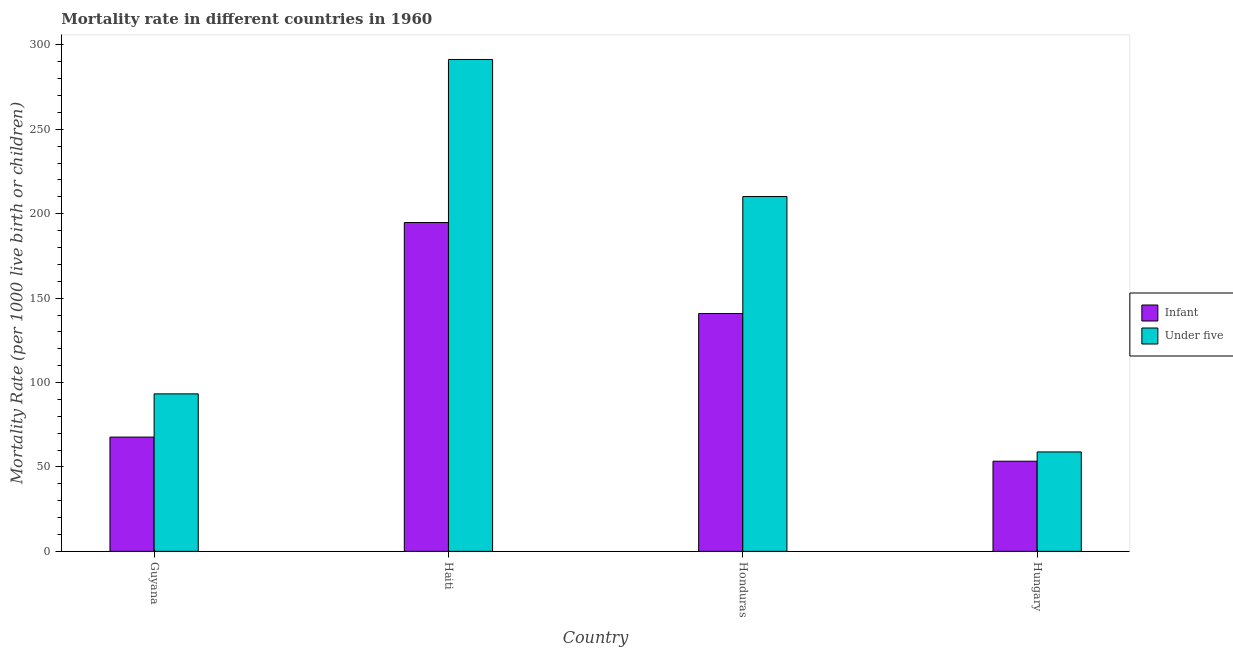Are the number of bars per tick equal to the number of legend labels?
Provide a succinct answer. Yes. How many bars are there on the 2nd tick from the left?
Your answer should be very brief. 2. How many bars are there on the 2nd tick from the right?
Offer a very short reply. 2. What is the label of the 2nd group of bars from the left?
Offer a terse response. Haiti. What is the infant mortality rate in Honduras?
Offer a very short reply. 140.9. Across all countries, what is the maximum infant mortality rate?
Give a very brief answer. 194.8. Across all countries, what is the minimum under-5 mortality rate?
Your answer should be compact. 58.9. In which country was the under-5 mortality rate maximum?
Your answer should be very brief. Haiti. In which country was the under-5 mortality rate minimum?
Your response must be concise. Hungary. What is the total infant mortality rate in the graph?
Your answer should be very brief. 456.8. What is the difference between the infant mortality rate in Guyana and that in Honduras?
Your response must be concise. -73.2. What is the difference between the infant mortality rate in Guyana and the under-5 mortality rate in Honduras?
Give a very brief answer. -142.5. What is the average under-5 mortality rate per country?
Your answer should be compact. 163.45. What is the difference between the infant mortality rate and under-5 mortality rate in Guyana?
Provide a succinct answer. -25.6. In how many countries, is the infant mortality rate greater than 290 ?
Ensure brevity in your answer.  0. What is the ratio of the infant mortality rate in Guyana to that in Honduras?
Your response must be concise. 0.48. What is the difference between the highest and the second highest infant mortality rate?
Your answer should be very brief. 53.9. What is the difference between the highest and the lowest infant mortality rate?
Ensure brevity in your answer.  141.4. In how many countries, is the infant mortality rate greater than the average infant mortality rate taken over all countries?
Provide a succinct answer. 2. Is the sum of the under-5 mortality rate in Guyana and Hungary greater than the maximum infant mortality rate across all countries?
Give a very brief answer. No. What does the 2nd bar from the left in Guyana represents?
Give a very brief answer. Under five. What does the 1st bar from the right in Hungary represents?
Provide a short and direct response. Under five. Are all the bars in the graph horizontal?
Make the answer very short. No. Does the graph contain grids?
Keep it short and to the point. No. Where does the legend appear in the graph?
Provide a succinct answer. Center right. How many legend labels are there?
Offer a terse response. 2. How are the legend labels stacked?
Provide a short and direct response. Vertical. What is the title of the graph?
Provide a short and direct response. Mortality rate in different countries in 1960. Does "Arms imports" appear as one of the legend labels in the graph?
Provide a succinct answer. No. What is the label or title of the X-axis?
Your answer should be compact. Country. What is the label or title of the Y-axis?
Keep it short and to the point. Mortality Rate (per 1000 live birth or children). What is the Mortality Rate (per 1000 live birth or children) in Infant in Guyana?
Your answer should be compact. 67.7. What is the Mortality Rate (per 1000 live birth or children) of Under five in Guyana?
Your answer should be compact. 93.3. What is the Mortality Rate (per 1000 live birth or children) in Infant in Haiti?
Offer a terse response. 194.8. What is the Mortality Rate (per 1000 live birth or children) of Under five in Haiti?
Your response must be concise. 291.4. What is the Mortality Rate (per 1000 live birth or children) in Infant in Honduras?
Give a very brief answer. 140.9. What is the Mortality Rate (per 1000 live birth or children) in Under five in Honduras?
Keep it short and to the point. 210.2. What is the Mortality Rate (per 1000 live birth or children) in Infant in Hungary?
Keep it short and to the point. 53.4. What is the Mortality Rate (per 1000 live birth or children) of Under five in Hungary?
Ensure brevity in your answer.  58.9. Across all countries, what is the maximum Mortality Rate (per 1000 live birth or children) of Infant?
Ensure brevity in your answer.  194.8. Across all countries, what is the maximum Mortality Rate (per 1000 live birth or children) of Under five?
Keep it short and to the point. 291.4. Across all countries, what is the minimum Mortality Rate (per 1000 live birth or children) in Infant?
Ensure brevity in your answer.  53.4. Across all countries, what is the minimum Mortality Rate (per 1000 live birth or children) of Under five?
Provide a short and direct response. 58.9. What is the total Mortality Rate (per 1000 live birth or children) of Infant in the graph?
Provide a short and direct response. 456.8. What is the total Mortality Rate (per 1000 live birth or children) in Under five in the graph?
Your answer should be compact. 653.8. What is the difference between the Mortality Rate (per 1000 live birth or children) of Infant in Guyana and that in Haiti?
Offer a very short reply. -127.1. What is the difference between the Mortality Rate (per 1000 live birth or children) of Under five in Guyana and that in Haiti?
Ensure brevity in your answer.  -198.1. What is the difference between the Mortality Rate (per 1000 live birth or children) in Infant in Guyana and that in Honduras?
Provide a short and direct response. -73.2. What is the difference between the Mortality Rate (per 1000 live birth or children) of Under five in Guyana and that in Honduras?
Keep it short and to the point. -116.9. What is the difference between the Mortality Rate (per 1000 live birth or children) in Under five in Guyana and that in Hungary?
Make the answer very short. 34.4. What is the difference between the Mortality Rate (per 1000 live birth or children) in Infant in Haiti and that in Honduras?
Ensure brevity in your answer.  53.9. What is the difference between the Mortality Rate (per 1000 live birth or children) of Under five in Haiti and that in Honduras?
Give a very brief answer. 81.2. What is the difference between the Mortality Rate (per 1000 live birth or children) in Infant in Haiti and that in Hungary?
Your answer should be very brief. 141.4. What is the difference between the Mortality Rate (per 1000 live birth or children) in Under five in Haiti and that in Hungary?
Give a very brief answer. 232.5. What is the difference between the Mortality Rate (per 1000 live birth or children) of Infant in Honduras and that in Hungary?
Keep it short and to the point. 87.5. What is the difference between the Mortality Rate (per 1000 live birth or children) of Under five in Honduras and that in Hungary?
Keep it short and to the point. 151.3. What is the difference between the Mortality Rate (per 1000 live birth or children) of Infant in Guyana and the Mortality Rate (per 1000 live birth or children) of Under five in Haiti?
Your response must be concise. -223.7. What is the difference between the Mortality Rate (per 1000 live birth or children) in Infant in Guyana and the Mortality Rate (per 1000 live birth or children) in Under five in Honduras?
Keep it short and to the point. -142.5. What is the difference between the Mortality Rate (per 1000 live birth or children) of Infant in Haiti and the Mortality Rate (per 1000 live birth or children) of Under five in Honduras?
Offer a very short reply. -15.4. What is the difference between the Mortality Rate (per 1000 live birth or children) in Infant in Haiti and the Mortality Rate (per 1000 live birth or children) in Under five in Hungary?
Your answer should be compact. 135.9. What is the difference between the Mortality Rate (per 1000 live birth or children) of Infant in Honduras and the Mortality Rate (per 1000 live birth or children) of Under five in Hungary?
Provide a short and direct response. 82. What is the average Mortality Rate (per 1000 live birth or children) in Infant per country?
Offer a very short reply. 114.2. What is the average Mortality Rate (per 1000 live birth or children) of Under five per country?
Make the answer very short. 163.45. What is the difference between the Mortality Rate (per 1000 live birth or children) of Infant and Mortality Rate (per 1000 live birth or children) of Under five in Guyana?
Make the answer very short. -25.6. What is the difference between the Mortality Rate (per 1000 live birth or children) in Infant and Mortality Rate (per 1000 live birth or children) in Under five in Haiti?
Your response must be concise. -96.6. What is the difference between the Mortality Rate (per 1000 live birth or children) of Infant and Mortality Rate (per 1000 live birth or children) of Under five in Honduras?
Provide a short and direct response. -69.3. What is the ratio of the Mortality Rate (per 1000 live birth or children) in Infant in Guyana to that in Haiti?
Your answer should be compact. 0.35. What is the ratio of the Mortality Rate (per 1000 live birth or children) in Under five in Guyana to that in Haiti?
Your answer should be compact. 0.32. What is the ratio of the Mortality Rate (per 1000 live birth or children) of Infant in Guyana to that in Honduras?
Your answer should be compact. 0.48. What is the ratio of the Mortality Rate (per 1000 live birth or children) of Under five in Guyana to that in Honduras?
Offer a very short reply. 0.44. What is the ratio of the Mortality Rate (per 1000 live birth or children) in Infant in Guyana to that in Hungary?
Make the answer very short. 1.27. What is the ratio of the Mortality Rate (per 1000 live birth or children) in Under five in Guyana to that in Hungary?
Offer a very short reply. 1.58. What is the ratio of the Mortality Rate (per 1000 live birth or children) in Infant in Haiti to that in Honduras?
Offer a terse response. 1.38. What is the ratio of the Mortality Rate (per 1000 live birth or children) of Under five in Haiti to that in Honduras?
Your answer should be compact. 1.39. What is the ratio of the Mortality Rate (per 1000 live birth or children) of Infant in Haiti to that in Hungary?
Give a very brief answer. 3.65. What is the ratio of the Mortality Rate (per 1000 live birth or children) in Under five in Haiti to that in Hungary?
Your answer should be compact. 4.95. What is the ratio of the Mortality Rate (per 1000 live birth or children) in Infant in Honduras to that in Hungary?
Your answer should be very brief. 2.64. What is the ratio of the Mortality Rate (per 1000 live birth or children) of Under five in Honduras to that in Hungary?
Ensure brevity in your answer.  3.57. What is the difference between the highest and the second highest Mortality Rate (per 1000 live birth or children) of Infant?
Give a very brief answer. 53.9. What is the difference between the highest and the second highest Mortality Rate (per 1000 live birth or children) of Under five?
Give a very brief answer. 81.2. What is the difference between the highest and the lowest Mortality Rate (per 1000 live birth or children) of Infant?
Offer a very short reply. 141.4. What is the difference between the highest and the lowest Mortality Rate (per 1000 live birth or children) in Under five?
Your answer should be very brief. 232.5. 